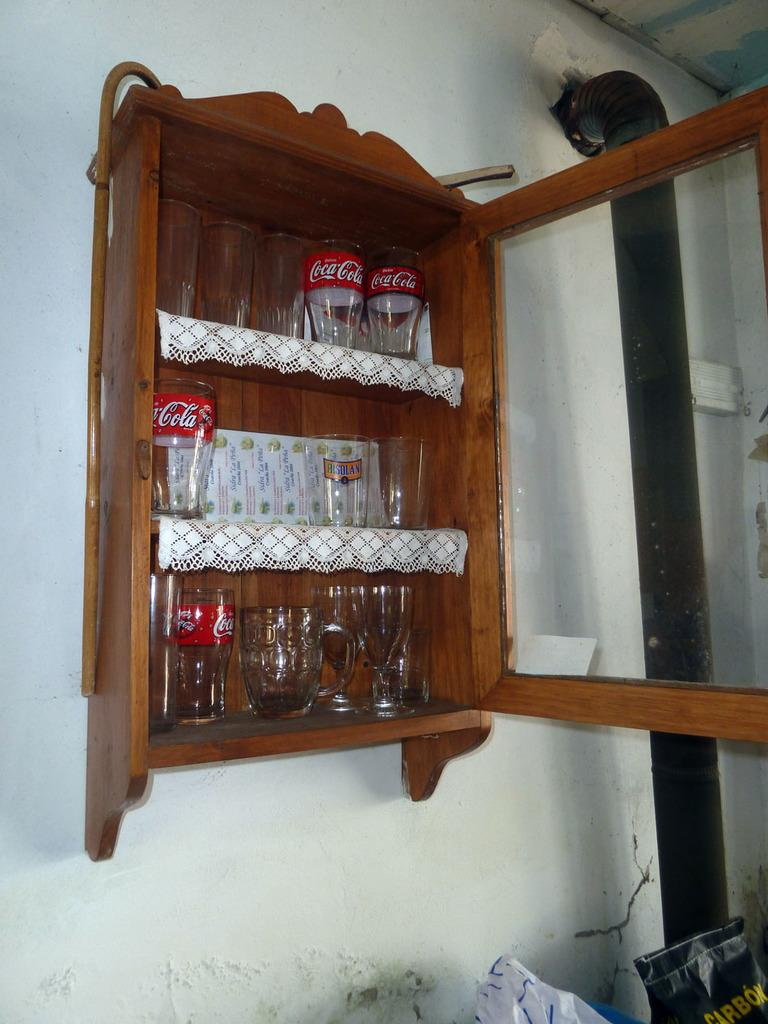What type of furniture is in the image? There is a small wooden almirah in the image. How is the almirah positioned in the image? The almirah is attached to the wall. What items are stored in the almirah? The almirah has glasses placed in it. What can be seen in the right corner of the image? There is a pipe in the right corner of the image. What type of pollution can be seen in the image? There is no pollution visible in the image; it only features a small wooden almirah, glasses, and a pipe. How many stars are visible in the image? There are no stars present in the image. 